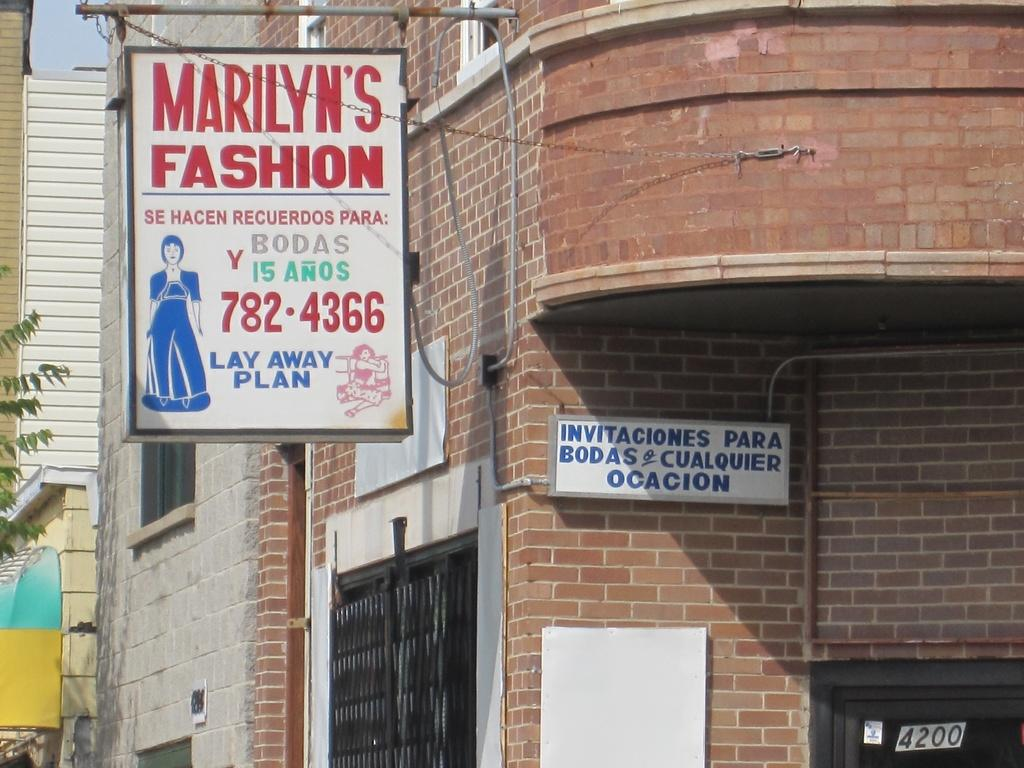What is attached to the building in the image? There is a board attached to a building in the image. What else can be seen in the background of the image? There are other buildings visible in the background of the image. What is the condition of the sky in the background of the image? The sky is clear in the background of the image. What type of bed can be seen supporting the board in the image? There is no bed present in the image, and the board is attached to a building, not supported by a bed. 